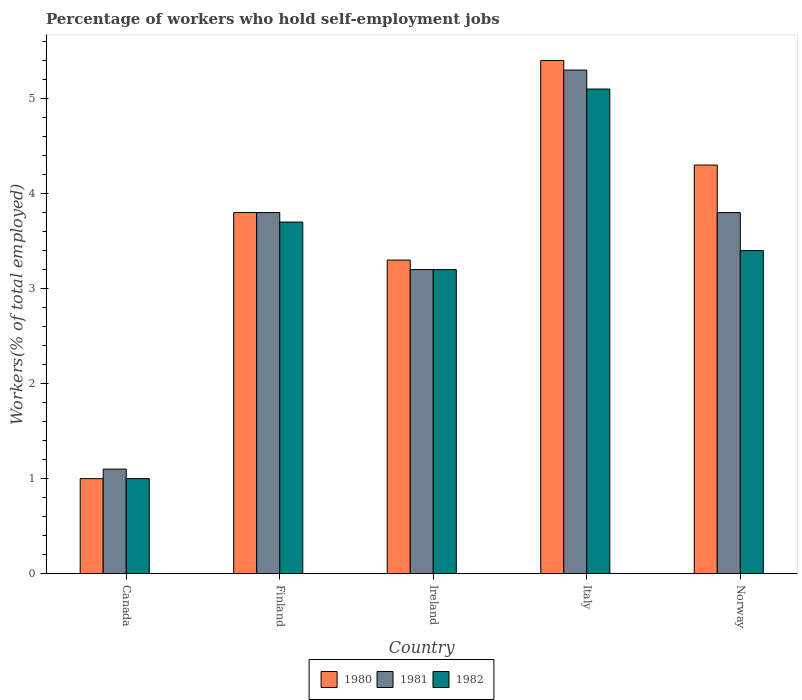How many groups of bars are there?
Your response must be concise. 5. How many bars are there on the 1st tick from the left?
Provide a short and direct response. 3. In how many cases, is the number of bars for a given country not equal to the number of legend labels?
Provide a succinct answer. 0. What is the percentage of self-employed workers in 1980 in Finland?
Keep it short and to the point. 3.8. Across all countries, what is the maximum percentage of self-employed workers in 1982?
Make the answer very short. 5.1. In which country was the percentage of self-employed workers in 1982 minimum?
Offer a very short reply. Canada. What is the total percentage of self-employed workers in 1982 in the graph?
Ensure brevity in your answer.  16.4. What is the difference between the percentage of self-employed workers in 1981 in Italy and that in Norway?
Give a very brief answer. 1.5. What is the difference between the percentage of self-employed workers in 1980 in Norway and the percentage of self-employed workers in 1982 in Ireland?
Give a very brief answer. 1.1. What is the average percentage of self-employed workers in 1982 per country?
Provide a succinct answer. 3.28. What is the difference between the percentage of self-employed workers of/in 1980 and percentage of self-employed workers of/in 1981 in Canada?
Offer a very short reply. -0.1. What is the ratio of the percentage of self-employed workers in 1980 in Canada to that in Finland?
Offer a very short reply. 0.26. Is the percentage of self-employed workers in 1981 in Ireland less than that in Italy?
Provide a succinct answer. Yes. Is the difference between the percentage of self-employed workers in 1980 in Finland and Norway greater than the difference between the percentage of self-employed workers in 1981 in Finland and Norway?
Your answer should be compact. No. What is the difference between the highest and the second highest percentage of self-employed workers in 1981?
Provide a succinct answer. -1.5. What is the difference between the highest and the lowest percentage of self-employed workers in 1982?
Make the answer very short. 4.1. What does the 3rd bar from the left in Norway represents?
Your answer should be compact. 1982. What does the 1st bar from the right in Italy represents?
Offer a terse response. 1982. How many bars are there?
Make the answer very short. 15. How many countries are there in the graph?
Keep it short and to the point. 5. Does the graph contain grids?
Keep it short and to the point. No. How are the legend labels stacked?
Your answer should be compact. Horizontal. What is the title of the graph?
Keep it short and to the point. Percentage of workers who hold self-employment jobs. Does "1965" appear as one of the legend labels in the graph?
Offer a very short reply. No. What is the label or title of the X-axis?
Give a very brief answer. Country. What is the label or title of the Y-axis?
Give a very brief answer. Workers(% of total employed). What is the Workers(% of total employed) in 1981 in Canada?
Offer a terse response. 1.1. What is the Workers(% of total employed) of 1982 in Canada?
Provide a short and direct response. 1. What is the Workers(% of total employed) of 1980 in Finland?
Your answer should be very brief. 3.8. What is the Workers(% of total employed) in 1981 in Finland?
Offer a terse response. 3.8. What is the Workers(% of total employed) in 1982 in Finland?
Give a very brief answer. 3.7. What is the Workers(% of total employed) of 1980 in Ireland?
Provide a short and direct response. 3.3. What is the Workers(% of total employed) of 1981 in Ireland?
Your answer should be very brief. 3.2. What is the Workers(% of total employed) in 1982 in Ireland?
Keep it short and to the point. 3.2. What is the Workers(% of total employed) of 1980 in Italy?
Provide a succinct answer. 5.4. What is the Workers(% of total employed) in 1981 in Italy?
Give a very brief answer. 5.3. What is the Workers(% of total employed) of 1982 in Italy?
Keep it short and to the point. 5.1. What is the Workers(% of total employed) of 1980 in Norway?
Provide a short and direct response. 4.3. What is the Workers(% of total employed) of 1981 in Norway?
Your answer should be very brief. 3.8. What is the Workers(% of total employed) in 1982 in Norway?
Keep it short and to the point. 3.4. Across all countries, what is the maximum Workers(% of total employed) in 1980?
Your response must be concise. 5.4. Across all countries, what is the maximum Workers(% of total employed) in 1981?
Provide a short and direct response. 5.3. Across all countries, what is the maximum Workers(% of total employed) in 1982?
Your answer should be very brief. 5.1. Across all countries, what is the minimum Workers(% of total employed) in 1981?
Your response must be concise. 1.1. What is the total Workers(% of total employed) in 1981 in the graph?
Offer a terse response. 17.2. What is the difference between the Workers(% of total employed) in 1980 in Canada and that in Finland?
Offer a terse response. -2.8. What is the difference between the Workers(% of total employed) in 1981 in Canada and that in Ireland?
Offer a very short reply. -2.1. What is the difference between the Workers(% of total employed) of 1982 in Canada and that in Ireland?
Keep it short and to the point. -2.2. What is the difference between the Workers(% of total employed) in 1981 in Canada and that in Italy?
Provide a succinct answer. -4.2. What is the difference between the Workers(% of total employed) of 1982 in Canada and that in Norway?
Keep it short and to the point. -2.4. What is the difference between the Workers(% of total employed) of 1981 in Finland and that in Ireland?
Offer a terse response. 0.6. What is the difference between the Workers(% of total employed) in 1982 in Finland and that in Ireland?
Make the answer very short. 0.5. What is the difference between the Workers(% of total employed) in 1981 in Finland and that in Italy?
Your answer should be very brief. -1.5. What is the difference between the Workers(% of total employed) of 1980 in Ireland and that in Italy?
Your answer should be very brief. -2.1. What is the difference between the Workers(% of total employed) in 1982 in Ireland and that in Italy?
Provide a short and direct response. -1.9. What is the difference between the Workers(% of total employed) in 1980 in Italy and that in Norway?
Ensure brevity in your answer.  1.1. What is the difference between the Workers(% of total employed) in 1981 in Italy and that in Norway?
Ensure brevity in your answer.  1.5. What is the difference between the Workers(% of total employed) in 1980 in Canada and the Workers(% of total employed) in 1981 in Finland?
Offer a terse response. -2.8. What is the difference between the Workers(% of total employed) of 1980 in Canada and the Workers(% of total employed) of 1982 in Finland?
Make the answer very short. -2.7. What is the difference between the Workers(% of total employed) of 1981 in Canada and the Workers(% of total employed) of 1982 in Finland?
Offer a terse response. -2.6. What is the difference between the Workers(% of total employed) in 1980 in Canada and the Workers(% of total employed) in 1982 in Italy?
Your answer should be compact. -4.1. What is the difference between the Workers(% of total employed) of 1981 in Canada and the Workers(% of total employed) of 1982 in Italy?
Provide a succinct answer. -4. What is the difference between the Workers(% of total employed) in 1980 in Canada and the Workers(% of total employed) in 1982 in Norway?
Ensure brevity in your answer.  -2.4. What is the difference between the Workers(% of total employed) in 1981 in Canada and the Workers(% of total employed) in 1982 in Norway?
Your answer should be very brief. -2.3. What is the difference between the Workers(% of total employed) of 1980 in Finland and the Workers(% of total employed) of 1981 in Ireland?
Offer a very short reply. 0.6. What is the difference between the Workers(% of total employed) in 1980 in Finland and the Workers(% of total employed) in 1982 in Ireland?
Provide a succinct answer. 0.6. What is the difference between the Workers(% of total employed) in 1980 in Finland and the Workers(% of total employed) in 1981 in Italy?
Provide a short and direct response. -1.5. What is the difference between the Workers(% of total employed) of 1980 in Finland and the Workers(% of total employed) of 1982 in Italy?
Your answer should be very brief. -1.3. What is the difference between the Workers(% of total employed) in 1980 in Finland and the Workers(% of total employed) in 1982 in Norway?
Your answer should be compact. 0.4. What is the difference between the Workers(% of total employed) in 1980 in Ireland and the Workers(% of total employed) in 1981 in Norway?
Offer a very short reply. -0.5. What is the difference between the Workers(% of total employed) of 1981 in Ireland and the Workers(% of total employed) of 1982 in Norway?
Provide a succinct answer. -0.2. What is the average Workers(% of total employed) of 1980 per country?
Keep it short and to the point. 3.56. What is the average Workers(% of total employed) in 1981 per country?
Give a very brief answer. 3.44. What is the average Workers(% of total employed) of 1982 per country?
Provide a short and direct response. 3.28. What is the difference between the Workers(% of total employed) of 1980 and Workers(% of total employed) of 1982 in Finland?
Your response must be concise. 0.1. What is the difference between the Workers(% of total employed) of 1980 and Workers(% of total employed) of 1981 in Ireland?
Give a very brief answer. 0.1. What is the difference between the Workers(% of total employed) in 1980 and Workers(% of total employed) in 1982 in Ireland?
Give a very brief answer. 0.1. What is the difference between the Workers(% of total employed) of 1980 and Workers(% of total employed) of 1981 in Italy?
Your answer should be compact. 0.1. What is the difference between the Workers(% of total employed) in 1980 and Workers(% of total employed) in 1982 in Italy?
Give a very brief answer. 0.3. What is the difference between the Workers(% of total employed) of 1981 and Workers(% of total employed) of 1982 in Italy?
Keep it short and to the point. 0.2. What is the difference between the Workers(% of total employed) of 1980 and Workers(% of total employed) of 1981 in Norway?
Provide a short and direct response. 0.5. What is the ratio of the Workers(% of total employed) of 1980 in Canada to that in Finland?
Make the answer very short. 0.26. What is the ratio of the Workers(% of total employed) of 1981 in Canada to that in Finland?
Make the answer very short. 0.29. What is the ratio of the Workers(% of total employed) of 1982 in Canada to that in Finland?
Give a very brief answer. 0.27. What is the ratio of the Workers(% of total employed) of 1980 in Canada to that in Ireland?
Your answer should be very brief. 0.3. What is the ratio of the Workers(% of total employed) in 1981 in Canada to that in Ireland?
Keep it short and to the point. 0.34. What is the ratio of the Workers(% of total employed) of 1982 in Canada to that in Ireland?
Make the answer very short. 0.31. What is the ratio of the Workers(% of total employed) of 1980 in Canada to that in Italy?
Offer a very short reply. 0.19. What is the ratio of the Workers(% of total employed) in 1981 in Canada to that in Italy?
Ensure brevity in your answer.  0.21. What is the ratio of the Workers(% of total employed) of 1982 in Canada to that in Italy?
Your answer should be very brief. 0.2. What is the ratio of the Workers(% of total employed) in 1980 in Canada to that in Norway?
Provide a succinct answer. 0.23. What is the ratio of the Workers(% of total employed) of 1981 in Canada to that in Norway?
Make the answer very short. 0.29. What is the ratio of the Workers(% of total employed) in 1982 in Canada to that in Norway?
Your answer should be compact. 0.29. What is the ratio of the Workers(% of total employed) of 1980 in Finland to that in Ireland?
Your response must be concise. 1.15. What is the ratio of the Workers(% of total employed) of 1981 in Finland to that in Ireland?
Keep it short and to the point. 1.19. What is the ratio of the Workers(% of total employed) in 1982 in Finland to that in Ireland?
Give a very brief answer. 1.16. What is the ratio of the Workers(% of total employed) in 1980 in Finland to that in Italy?
Keep it short and to the point. 0.7. What is the ratio of the Workers(% of total employed) of 1981 in Finland to that in Italy?
Ensure brevity in your answer.  0.72. What is the ratio of the Workers(% of total employed) in 1982 in Finland to that in Italy?
Ensure brevity in your answer.  0.73. What is the ratio of the Workers(% of total employed) in 1980 in Finland to that in Norway?
Keep it short and to the point. 0.88. What is the ratio of the Workers(% of total employed) of 1981 in Finland to that in Norway?
Give a very brief answer. 1. What is the ratio of the Workers(% of total employed) of 1982 in Finland to that in Norway?
Your response must be concise. 1.09. What is the ratio of the Workers(% of total employed) in 1980 in Ireland to that in Italy?
Your answer should be compact. 0.61. What is the ratio of the Workers(% of total employed) in 1981 in Ireland to that in Italy?
Your answer should be compact. 0.6. What is the ratio of the Workers(% of total employed) of 1982 in Ireland to that in Italy?
Make the answer very short. 0.63. What is the ratio of the Workers(% of total employed) in 1980 in Ireland to that in Norway?
Offer a terse response. 0.77. What is the ratio of the Workers(% of total employed) of 1981 in Ireland to that in Norway?
Provide a short and direct response. 0.84. What is the ratio of the Workers(% of total employed) of 1982 in Ireland to that in Norway?
Offer a very short reply. 0.94. What is the ratio of the Workers(% of total employed) of 1980 in Italy to that in Norway?
Your response must be concise. 1.26. What is the ratio of the Workers(% of total employed) in 1981 in Italy to that in Norway?
Your response must be concise. 1.39. What is the difference between the highest and the second highest Workers(% of total employed) in 1981?
Your answer should be compact. 1.5. What is the difference between the highest and the lowest Workers(% of total employed) in 1980?
Your answer should be very brief. 4.4. 